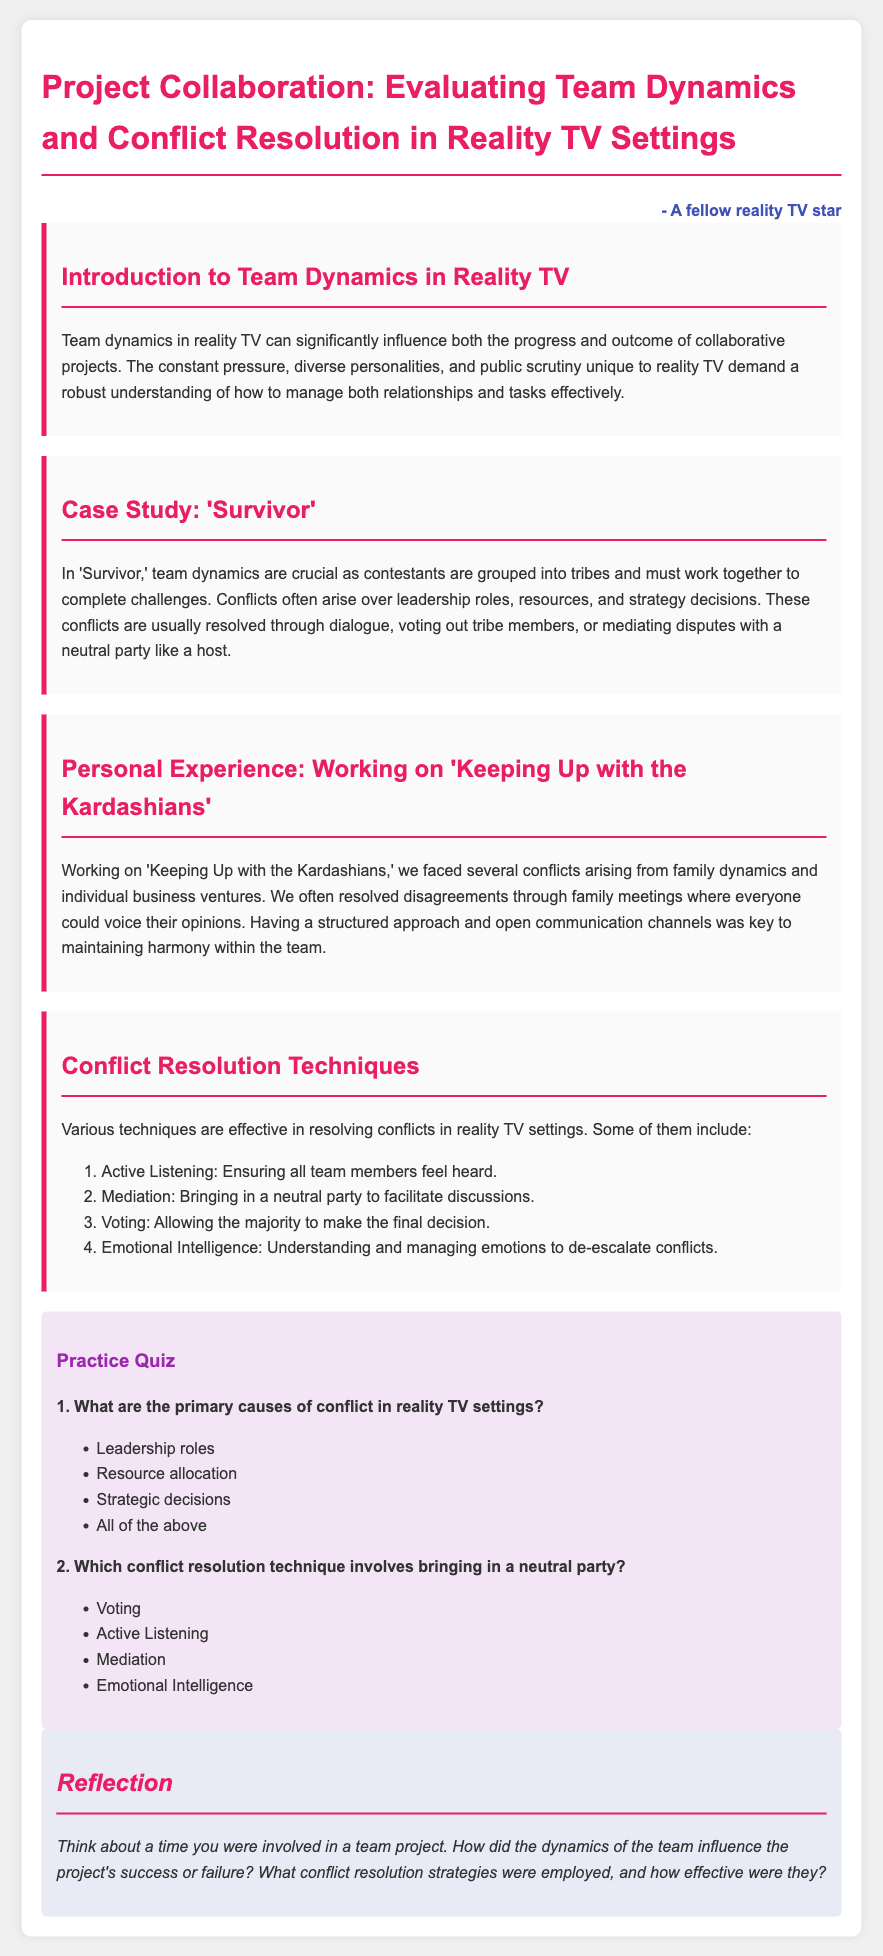What are the primary causes of conflict in reality TV settings? The document lists the primary causes of conflict, which include leadership roles, resource allocation, and strategic decisions as well as stating that there are multiple causes together as 'all of the above'.
Answer: All of the above Which reality TV show is used as a case study in the document? The document explicitly mentions the show that is analyzed, which is 'Survivor'.
Answer: Survivor What is one conflict resolution technique mentioned in the document? The document lists various conflict resolution techniques, one of which is 'Active Listening'.
Answer: Active Listening How are conflicts often resolved in 'Survivor'? The document describes methods used to resolve conflicts in 'Survivor', mentioning dialogue, voting out tribe members, or mediation with a host.
Answer: Dialogue, voting out tribe members, or mediation What structured approach did the Kardashians use to resolve conflicts? The document mentions that Kardashian family conflicts were often resolved through family meetings where everyone could voice their opinions.
Answer: Family meetings How many conflict resolution techniques are listed in the document? The document provides a list of techniques, and it specifies that there are four total.
Answer: Four What personal experience is shared in the document? The document discusses experiences related to the show where family dynamics and individual business ventures led to conflicts.
Answer: Keeping Up with the Kardashians What does emotional intelligence help with in conflict resolution? The document states that emotional intelligence helps in understanding and managing emotions to de-escalate conflicts.
Answer: De-escalate conflicts What is the overall theme of the document? The document centers on the evaluation of team dynamics and conflict resolution specifically in the context of reality TV settings.
Answer: Team dynamics and conflict resolution in reality TV 